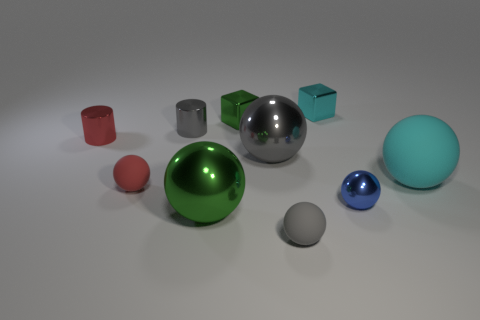Is there anything else that is made of the same material as the large cyan object?
Offer a terse response. Yes. What number of things are either large red cylinders or matte objects right of the big gray metal sphere?
Keep it short and to the point. 2. There is a big metallic thing in front of the tiny metallic ball; what is its color?
Your response must be concise. Green. The red matte thing is what shape?
Your answer should be compact. Sphere. What material is the small gray thing that is behind the tiny shiny sphere that is in front of the small gray metal object made of?
Your answer should be very brief. Metal. What number of other objects are the same material as the tiny cyan object?
Ensure brevity in your answer.  6. What material is the red thing that is the same size as the red sphere?
Your response must be concise. Metal. Are there more cyan metallic cubes on the left side of the small red metallic thing than cyan rubber spheres that are on the right side of the big cyan thing?
Provide a succinct answer. No. Are there any other shiny things that have the same shape as the large green object?
Give a very brief answer. Yes. What is the shape of the gray metal thing that is the same size as the green sphere?
Provide a short and direct response. Sphere. 